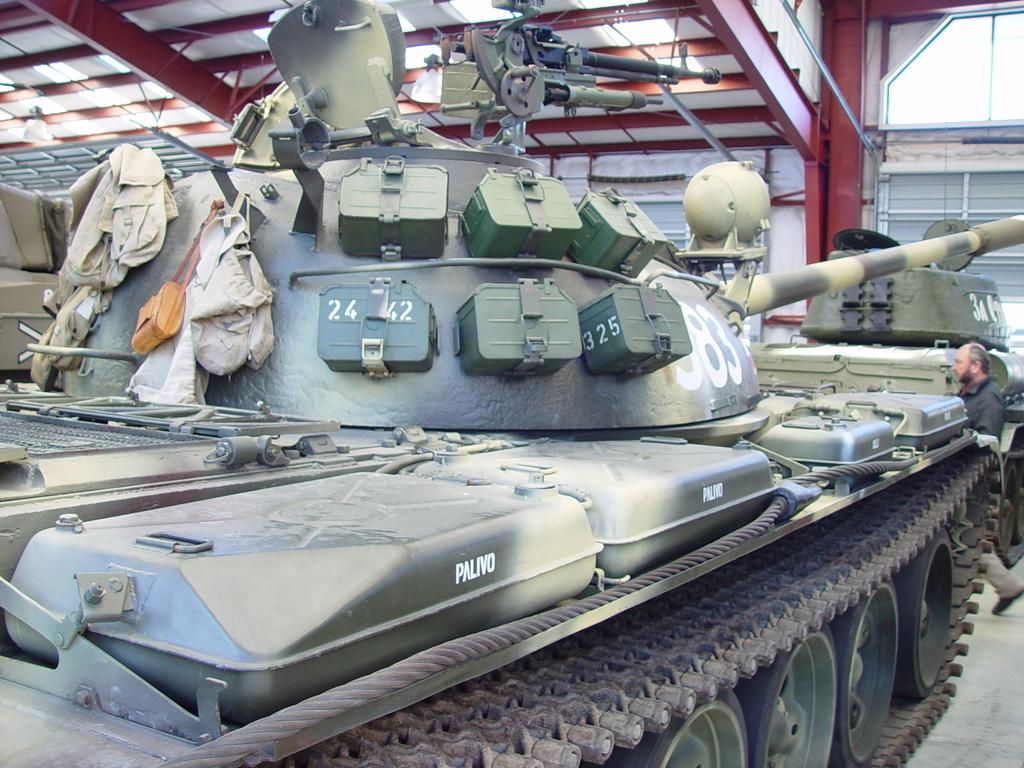What is the main subject of the image? The main subject of the image is a battle tank. Can you describe the color of the battle tank? The battle tank is green. What is happening on the right side of the image? There is a man walking on the right side of the image. What type of roof is visible at the top of the image? There is an iron roof visible at the top of the image. What type of cherry is being used as a decoration on the battle tank in the image? There are no cherries present in the image, and the battle tank is not decorated with any fruits. 